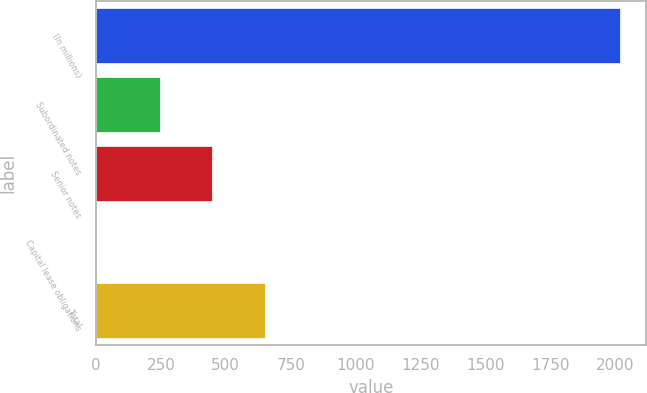Convert chart to OTSL. <chart><loc_0><loc_0><loc_500><loc_500><bar_chart><fcel>(In millions)<fcel>Subordinated notes<fcel>Senior notes<fcel>Capital lease obligations<fcel>Total<nl><fcel>2016<fcel>246<fcel>447.5<fcel>1<fcel>649<nl></chart> 